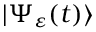<formula> <loc_0><loc_0><loc_500><loc_500>| \Psi _ { \varepsilon } ( t ) \rangle</formula> 